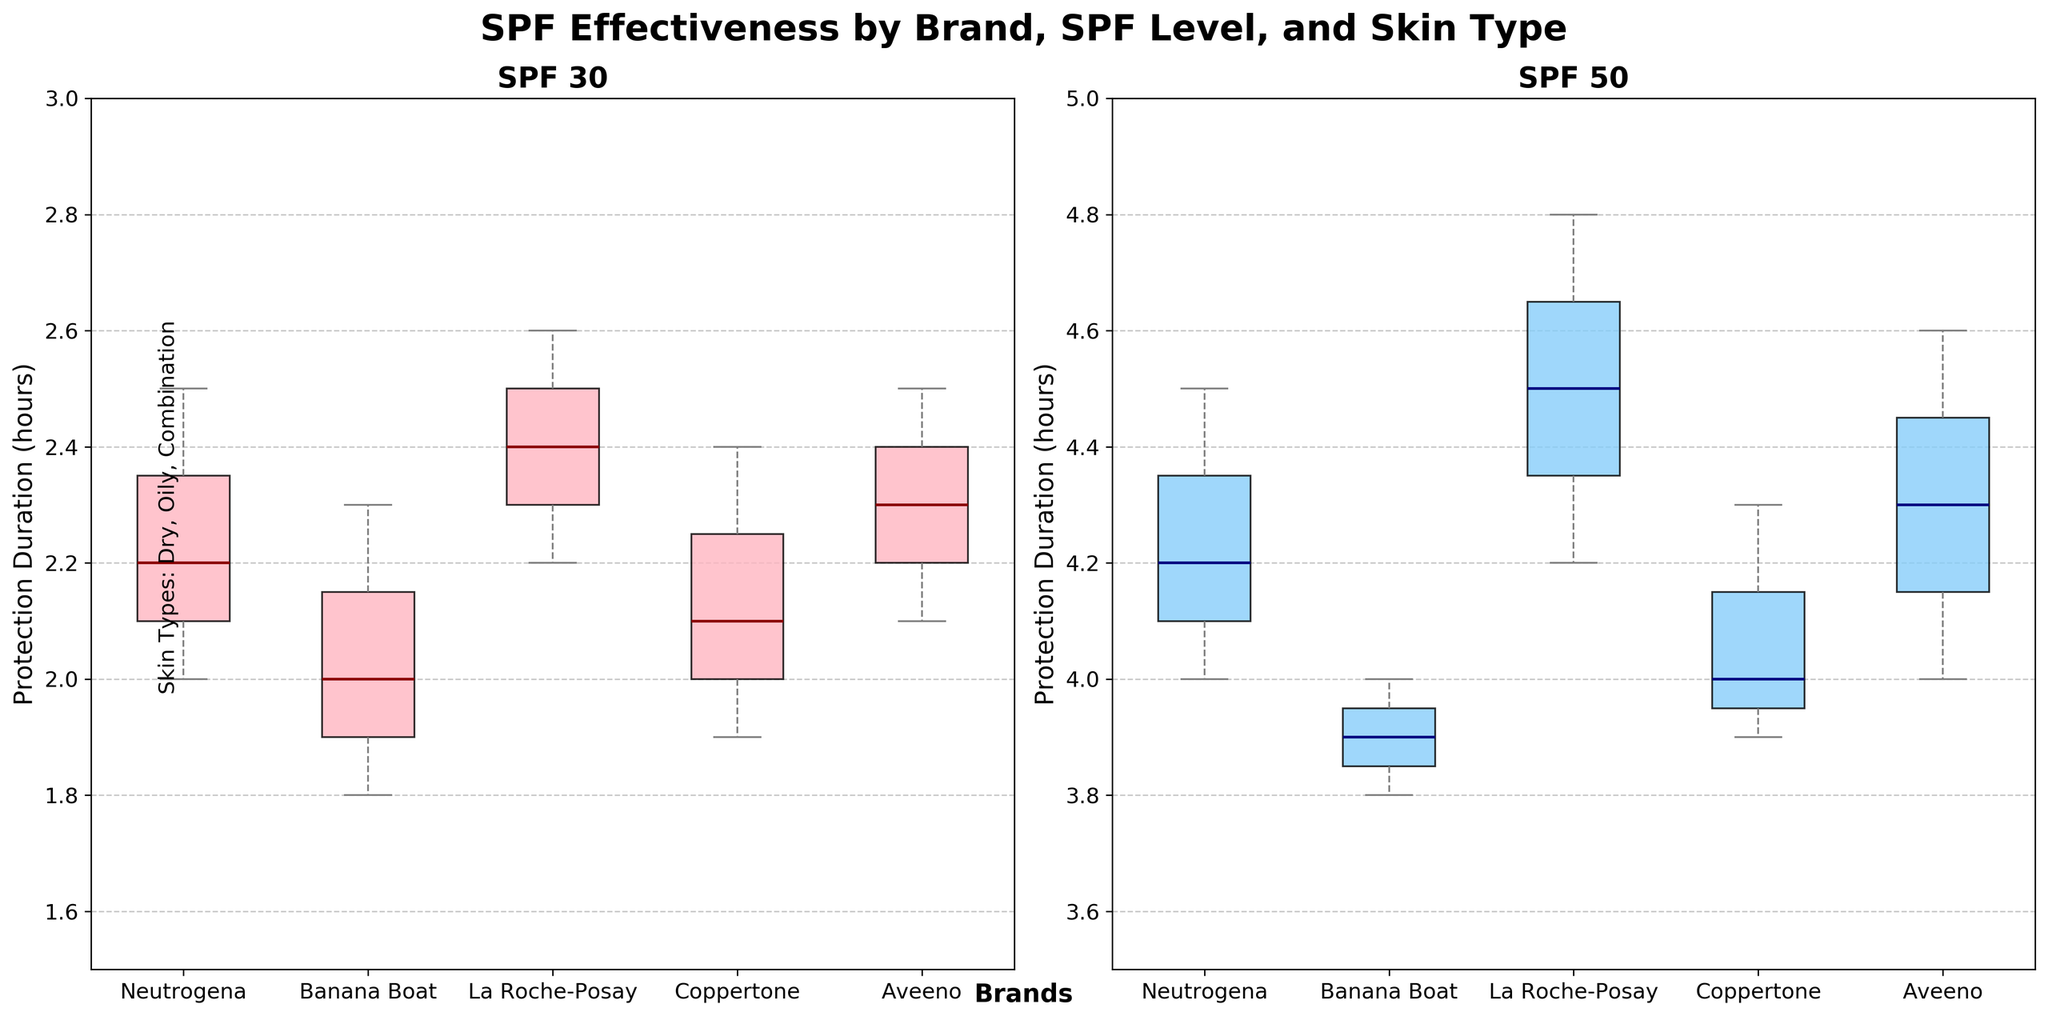What is the title of the figure? The overall title of the figure is written at the top. The title is 'SPF Effectiveness by Brand, SPF Level, and Skin Type'.
Answer: 'SPF Effectiveness by Brand, SPF Level, and Skin Type' What is the y-axis label in the SPF 30 subplot? The y-axis label is directly indicated on the left side of the SPF 30 subplot. It is 'Protection Duration (hours)'.
Answer: 'Protection Duration (hours)' Which brand has the highest median protection duration for SPF 50? Look for the brand with the highest median line (thick horizontal line in the box) in the SPF 50 subplot. La Roche-Posay has the highest median protection duration for SPF 50.
Answer: La Roche-Posay Between Neutrogena and Banana Boat, which one provides better protection duration on average for SPF 30? Compare the median lines (thick horizontal line within the boxes) of Neutrogena and Banana Boat in the SPF 30 subplot. Neutrogena has a higher median line compared to Banana Boat.
Answer: Neutrogena What is the range of protection duration for Coppertone with SPF 50? To find the range, look at the top and bottom whiskers of the Coppertone box in the SPF 50 subplot. The range is from 3.9 to 4.3 hours.
Answer: 3.9 to 4.3 hours Which skin type is mentioned in the figure text at the bottom? The figure text at the bottom mentions three skin types, which are stated clearly as 'Dry, Oily, Combination'.
Answer: Dry, Oily, Combination Does La Roche-Posay provide more consistent protection duration for SPF 30 or SPF 50? Consistency is indicated by the range and interquartile range (IQR) of the box plot. For La Roche-Posay, the SPF 50 subplot shows less spread of data compared to SPF 30, indicating more consistent protection duration for SPF 50.
Answer: SPF 50 Which SPF level, 30 or 50, provides generally longer protection duration across all brands? Compare the y-axis ranges for both SPF levels. SPF 50 subplot has higher values for protection duration compared to SPF 30.
Answer: SPF 50 